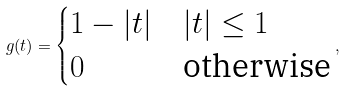Convert formula to latex. <formula><loc_0><loc_0><loc_500><loc_500>g ( t ) = \begin{cases} 1 - | t | & | t | \leq 1 \\ 0 & \text {otherwise} \\ \end{cases} ,</formula> 